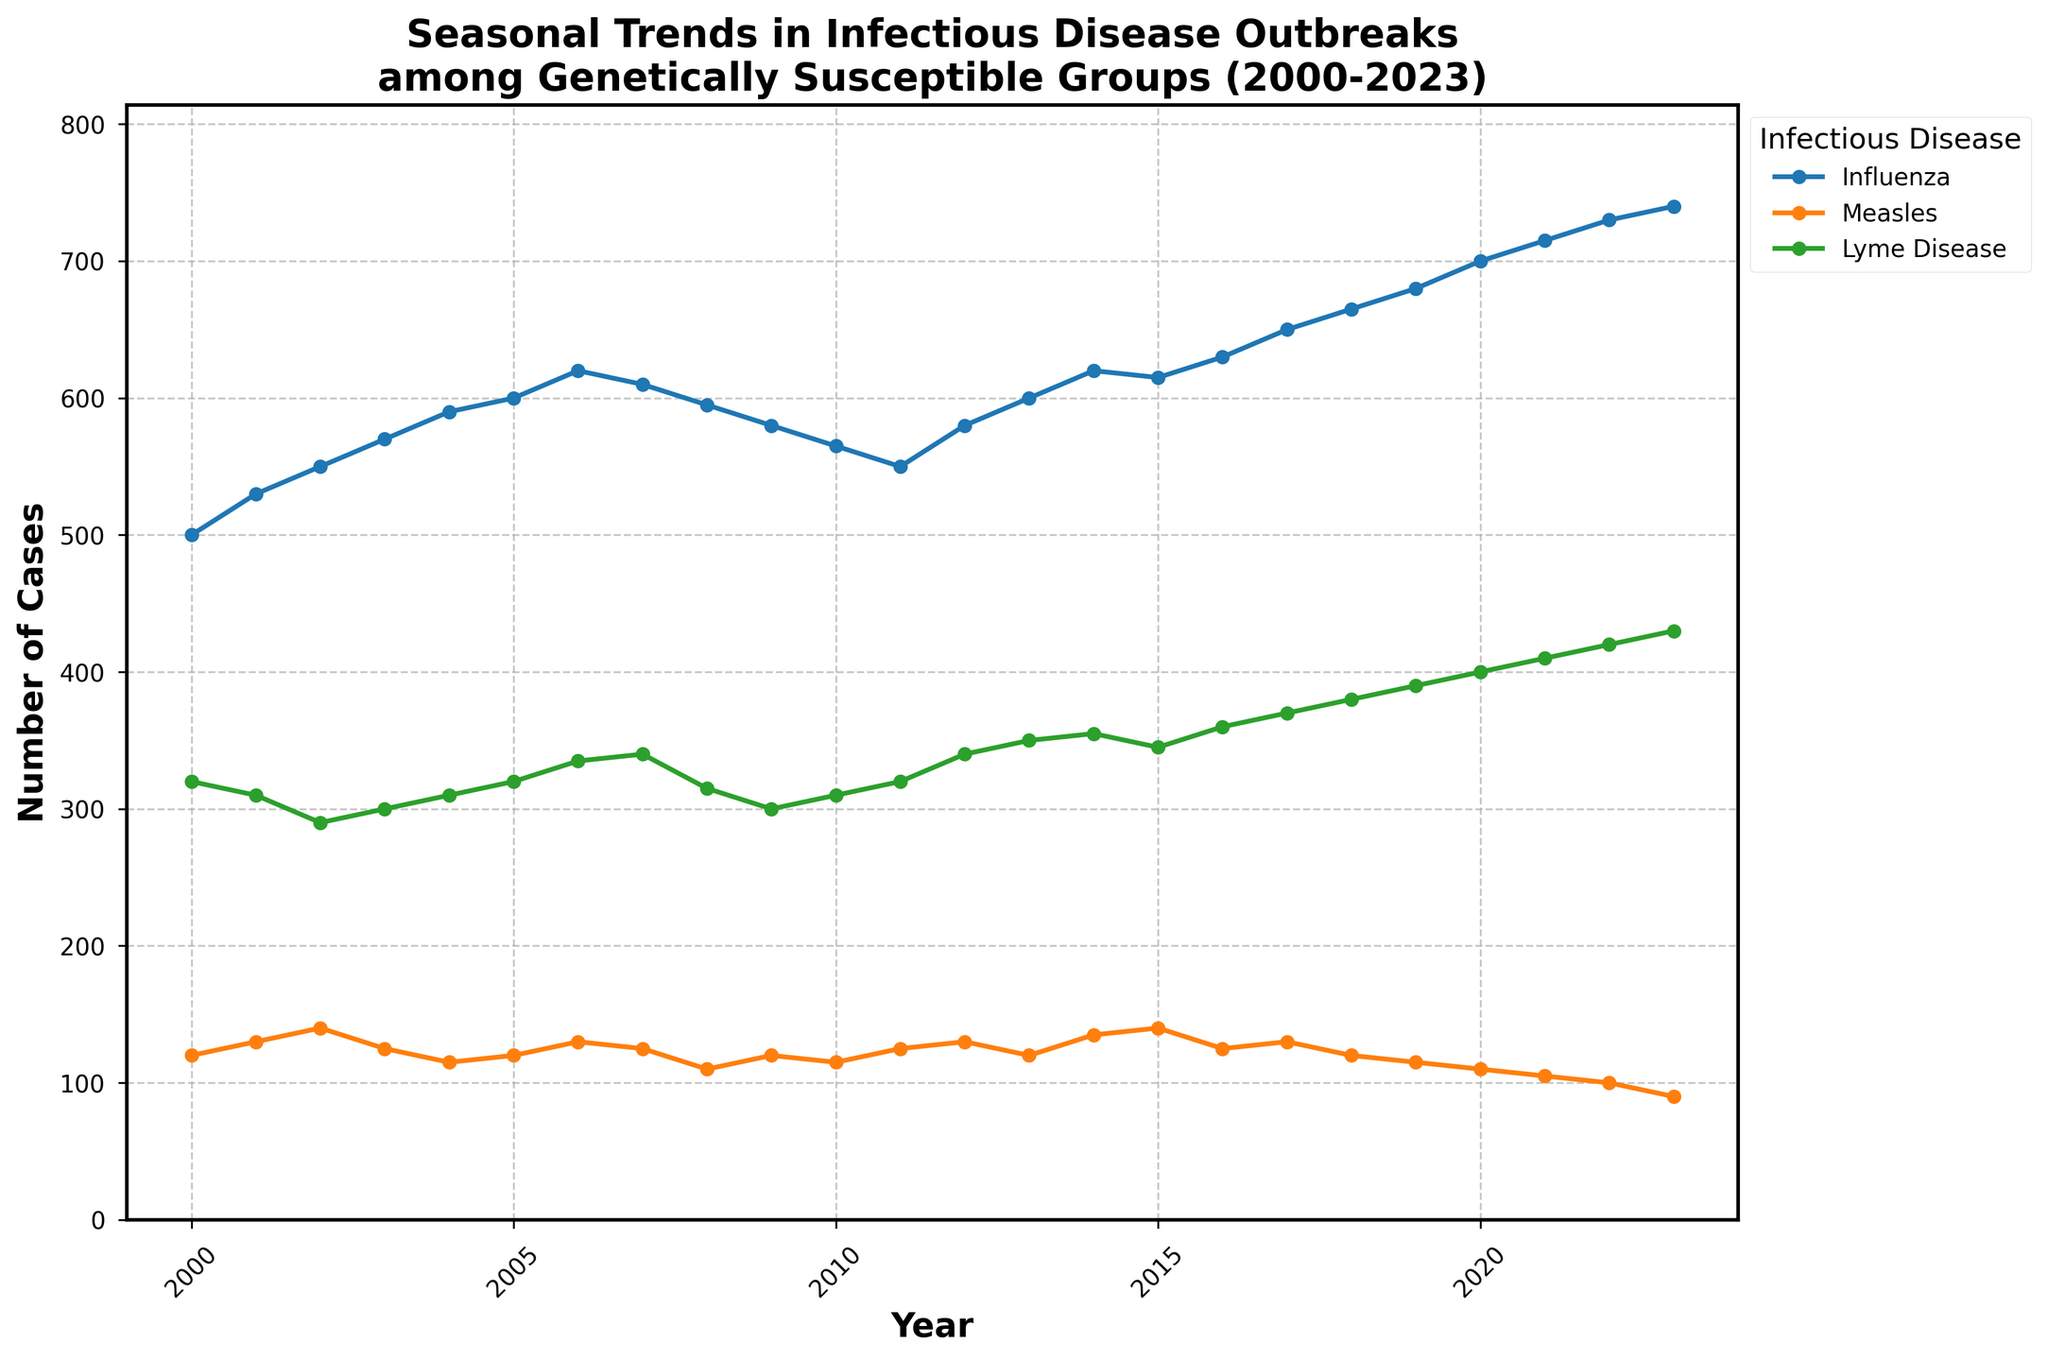What's the title of the figure? The title of the figure is located at the top of the plot and is presented in larger, bold text.
Answer: Seasonal Trends in Infectious Disease Outbreaks among Genetically Susceptible Groups (2000-2023) Which infectious disease generally shows the highest number of cases? By observing the plot, the disease with the most prominent upward trend and the highest number of cases throughout most of the years is Influenza.
Answer: Influenza How do the number of influenza cases in 2000 and 2023 compare? To compare the number of Influenza cases in these two years, locate the data points for Influenza in 2000 and 2023 on the plot and compare their respective heights. In 2000, the number is around 500, while in 2023, it is around 740.
Answer: The number of Influenza cases increased from 500 in 2000 to 740 in 2023 Which season shows the most consistent upward trend across the years? The trends for the different diseases across various seasons show different patterns. Influenza in winter has a consistent upward trend from 2000 to 2023.
Answer: Winter What is the range of Lyme Disease cases from 2000 to 2023? Look at the plot lines for Lyme Disease between 2000 and 2023 to find the minimum and maximum values, which appear to be approximately 290 and 430, respectively.
Answer: 290 - 430 What is the average number of measles cases reported in the spring seasons from 2000-2003? Identify the number of measles cases in the spring seasons of 2000 (120), 2001 (130), 2002 (140), and 2003 (125). Sum these numbers and divide by the number of years (4): (120 + 130 + 140 + 125) / 4 = 128.75.
Answer: 128.75 Which disease had the least variation in number of cases over the years? To determine this, examine the trends of each disease and look for consistent or flat lines. Measles has the least variation, staying relatively stable around 100 to 140 cases.
Answer: Measles Is there any significant change in the trend of Pacific Islanders' measles cases in recent years? Observe the plot line representing measles cases among Pacific Islanders. Notice a significant downward trend, especially noticeable after 2017.
Answer: Yes, there is a significant decrease Compare the trend lines for Lyme Disease and Measles over the given time period. Lyme Disease shows an increasing trend over the years, while Measles has remained relatively stable but with a slight overall decrease toward the latter years. Compare by looking at the slope and pattern of the lines.
Answer: Lyme Disease increased, Measles stable with a slight decrease 